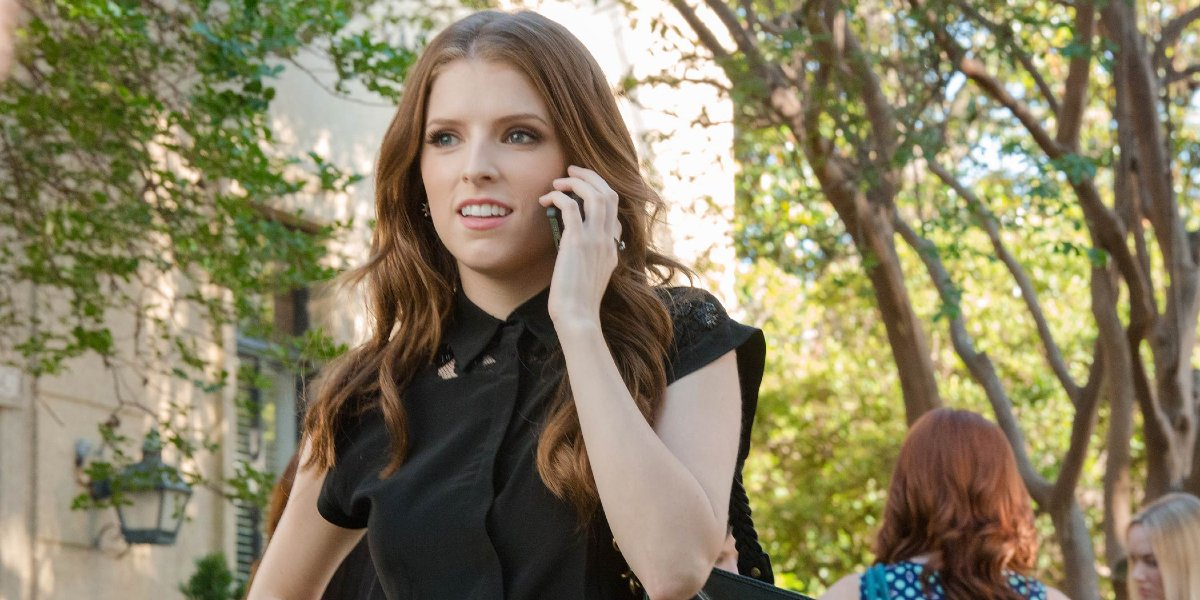What do you see happening in this image? In this image, a woman is captured in a candid moment while walking down a tree-lined street. She appears to be engaged in a phone conversation, with a concerned expression on her face. She is wearing a stylish black blouse with ruffled sleeves, and her loose waves of hair are bouncing with each step. The trees overhead create a natural canopy, casting dappled shadows on the sidewalk. This snapshot offers a glimpse into her day-to-day life, away from any professional context. 